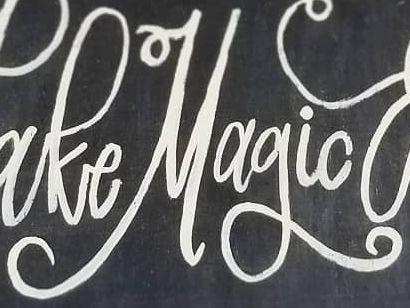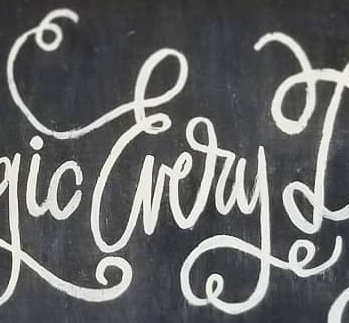What words are shown in these images in order, separated by a semicolon? Magic; Every 